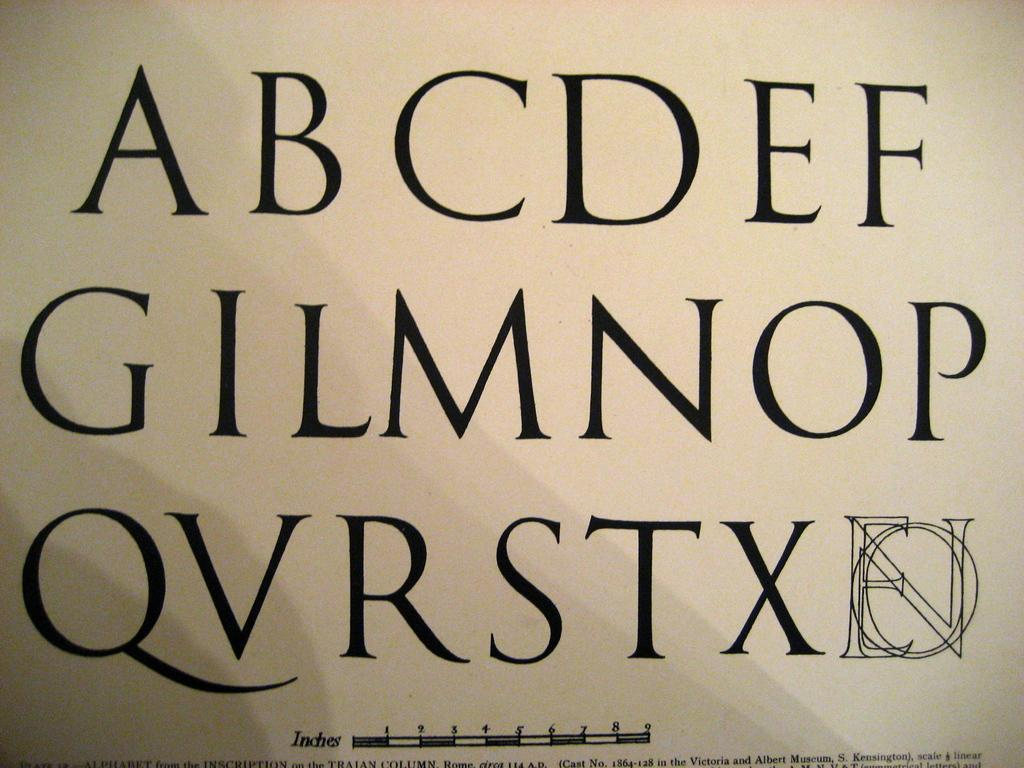<image>
Offer a succinct explanation of the picture presented. White background with the alphabets in black starting with the letter A. 